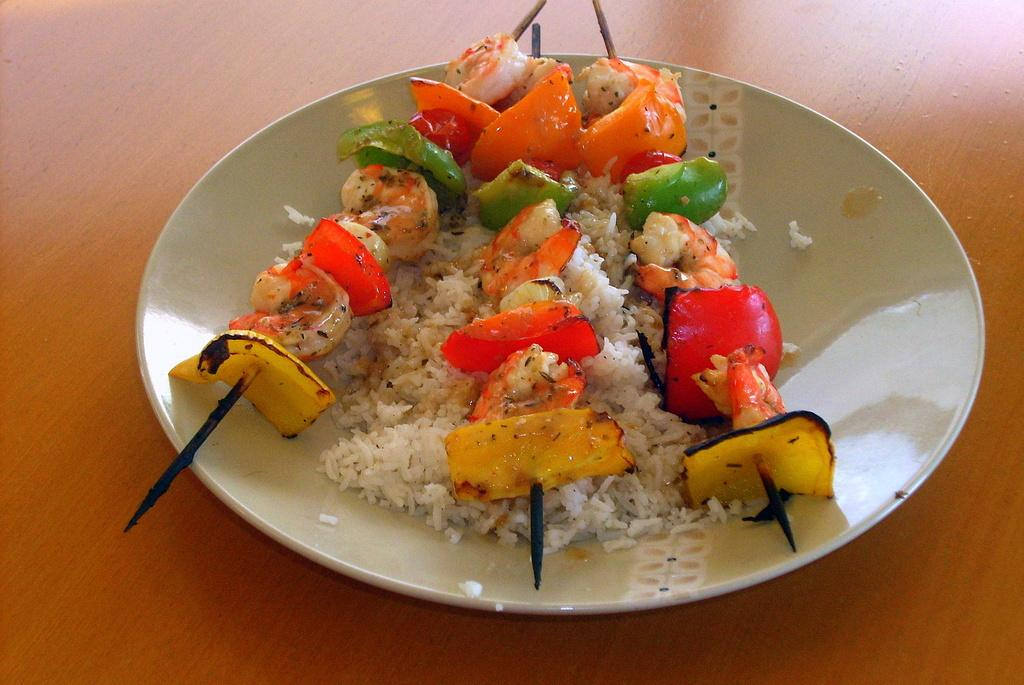What is on the serving plate in the image? The serving plate contains rice, pieces of vegetables, and pieces of meat on skewers. Where is the serving plate located? The serving plate is placed on a table. What type of food is present on the serving plate? The serving plate contains rice, vegetables, and meat on skewers. What is the opinion of the cork on the serving plate in the image? There is no cork present on the serving plate or in the image. 